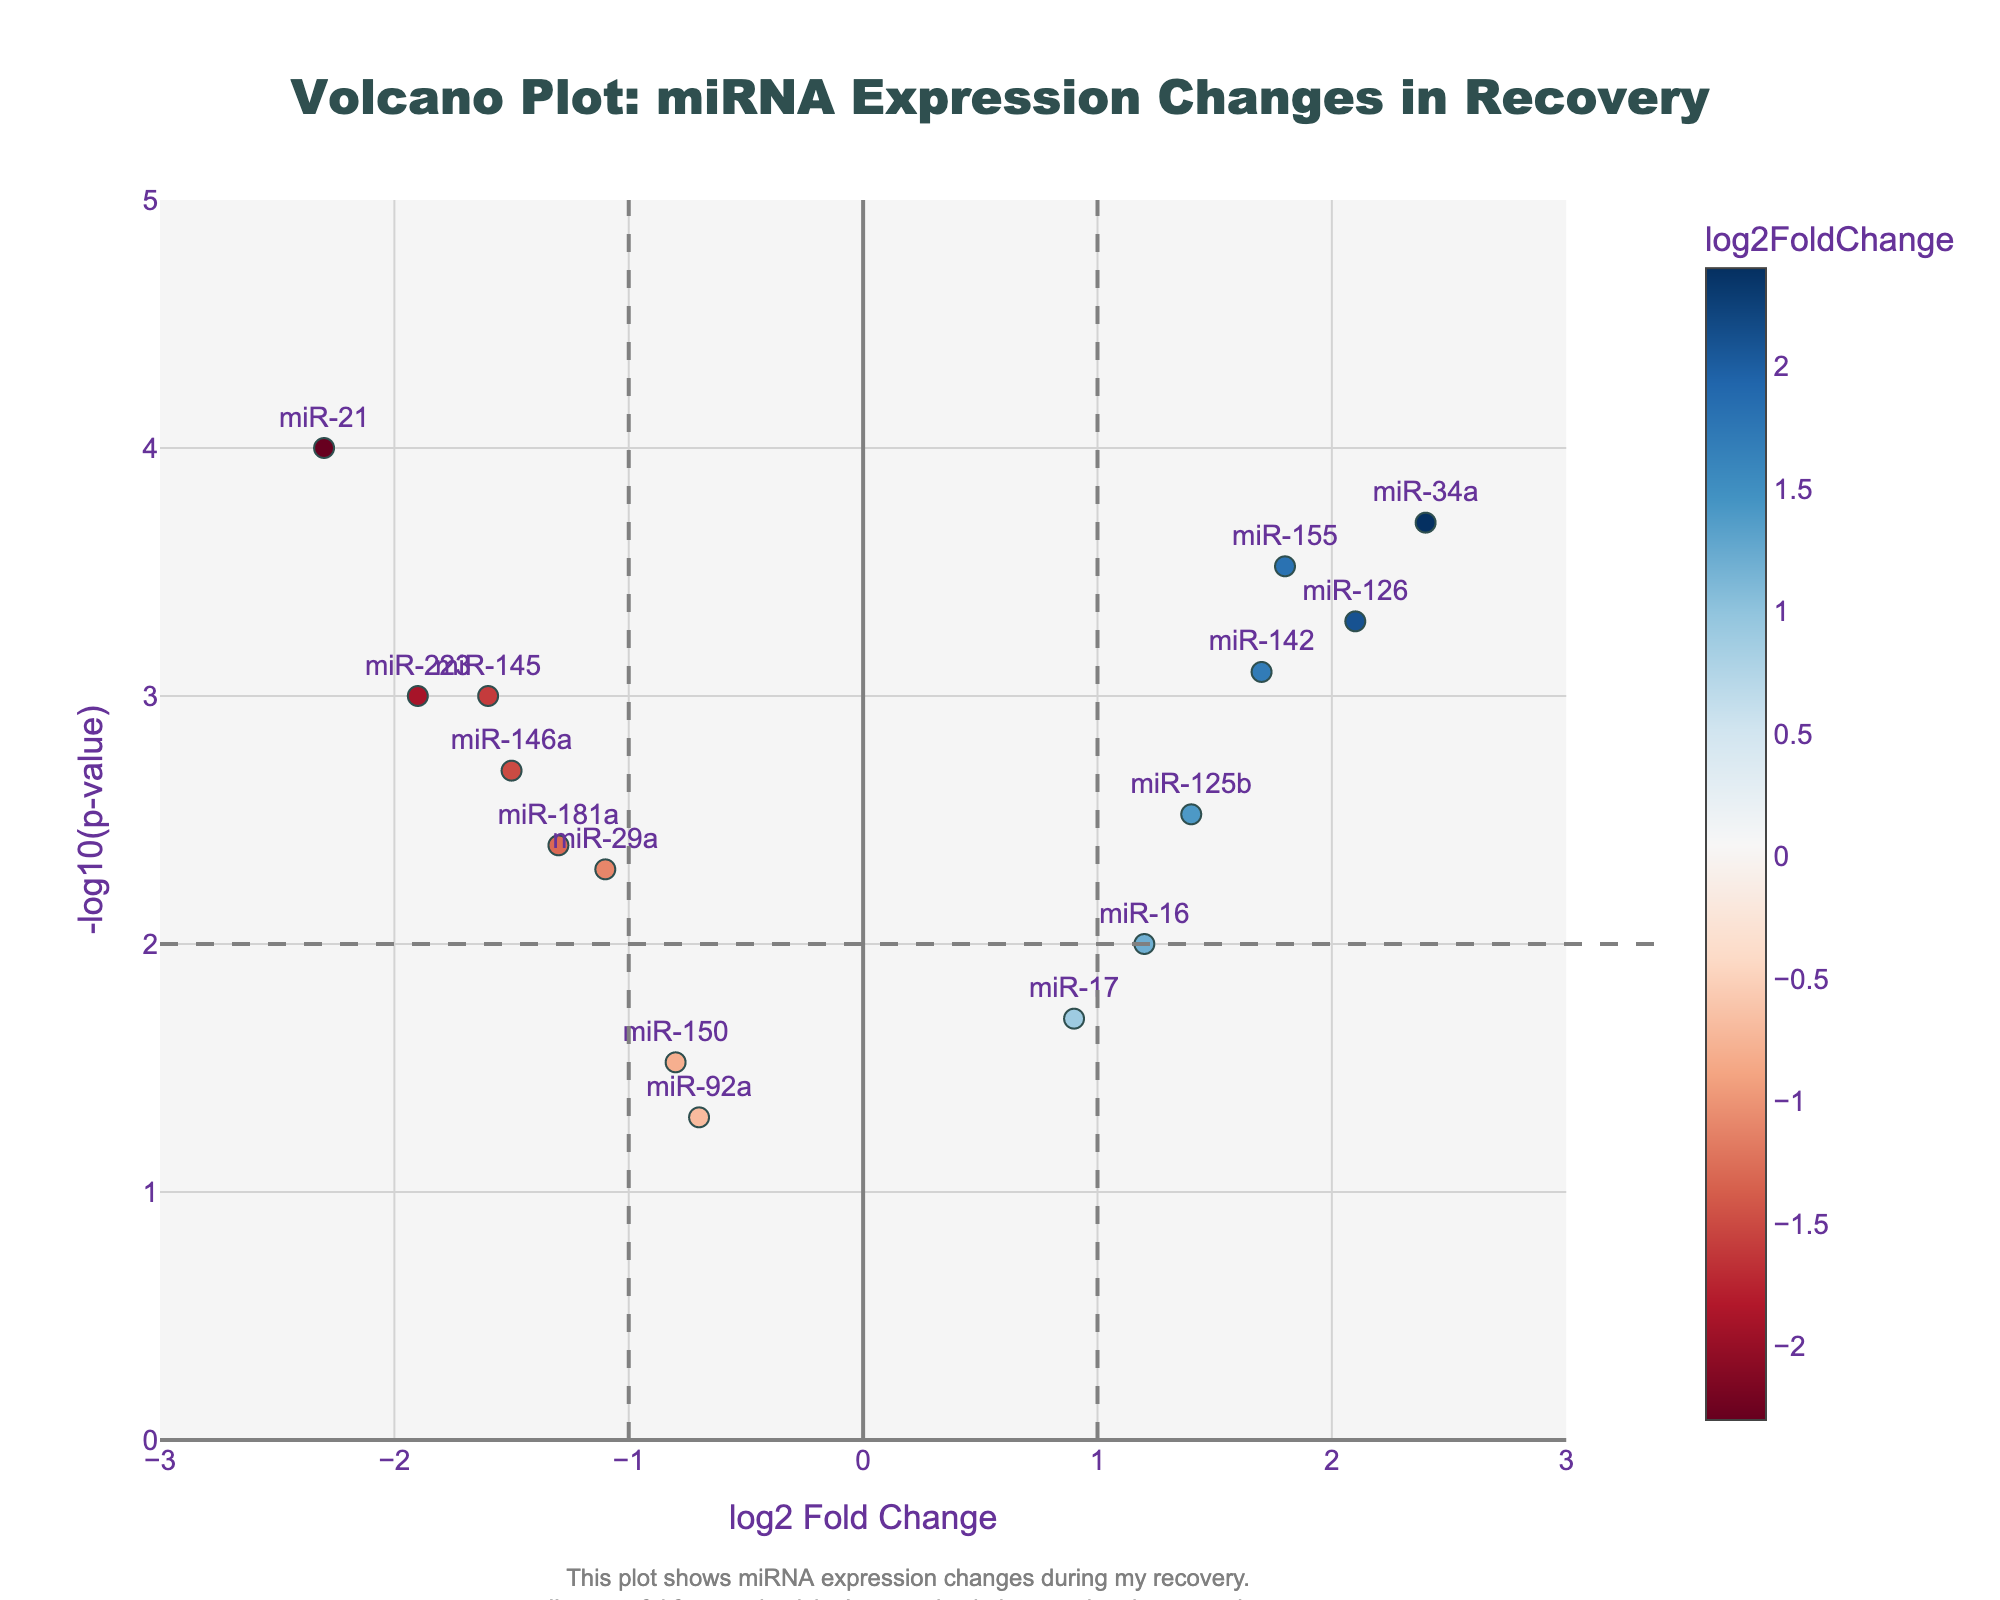How many miRNAs are shown in the plot? Count the number of unique miRNA labels scattered throughout the plot.
Answer: 15 What is the range of the log2 Fold Change values? Identify the smallest and largest log2 Fold Change values on the x-axis range which goes from -3 to 3.
Answer: -2.3 to 2.4 Which miRNA has the most significant p-value? Look for the data point with the highest -log10(p-value) on the y-axis. miR-21 has the highest position on the y-axis.
Answer: miR-21 What is the log2 Fold Change of miR-34a? Find the position of miR-34a on the plot and read its corresponding x-axis value.
Answer: 2.4 How many miRNAs have a log2 Fold Change greater than 1? Count all the miRNAs positioned to the right of the x=1 vertical line.
Answer: 4 Which miRNA has a negative log2 Fold Change and a highly significant p-value (below 0.001)? Look for miRNAs located to the left of zero on the x-axis and at a high position on the y-axis above -log10(p-value) of 3 (corresponding to p-value of 0.001).
Answer: miR-21 and miR-223 What is the log2 Fold Change difference between miR-126 and miR-155? Subtract the log2 Fold Change of miR-155 from that of miR-126. 2.1 - 1.8 = 0.3
Answer: 0.3 Do any miRNAs have a p-value lower than 0.0005? Check the plot for miRNAs with a -log10(p-value) position greater than 3.3, since -log10(0.0005) is approximately 3.3.
Answer: Yes (miR-34a and miR-21) Which miRNA shows the least significant p-value? Find the miRNA with the lowest position on the y-axis. miR-92a has the lowest position.
Answer: miR-92a Are there more miRNAs with positive or negative log2 Fold Changes? Compare the count of miRNAs positioned to the right of zero on the x-axis with those on the left. There are 8 with positive and 7 with negative log2 Fold Changes.
Answer: Positive 